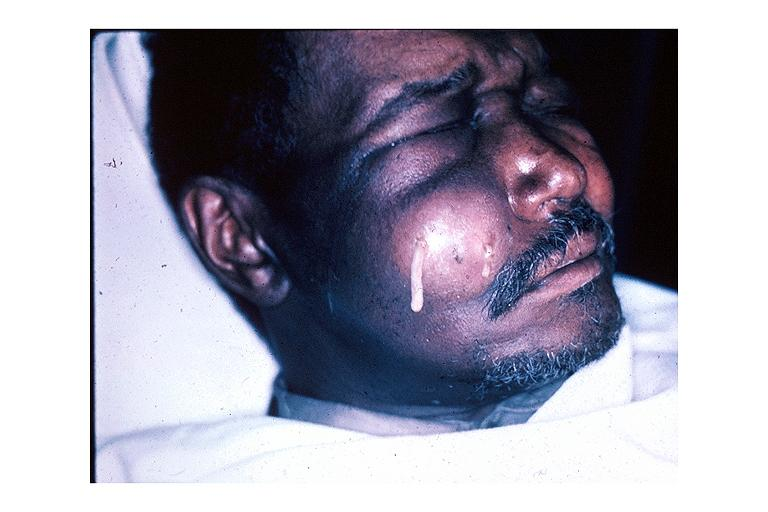does choanal patency show facial abscess?
Answer the question using a single word or phrase. No 